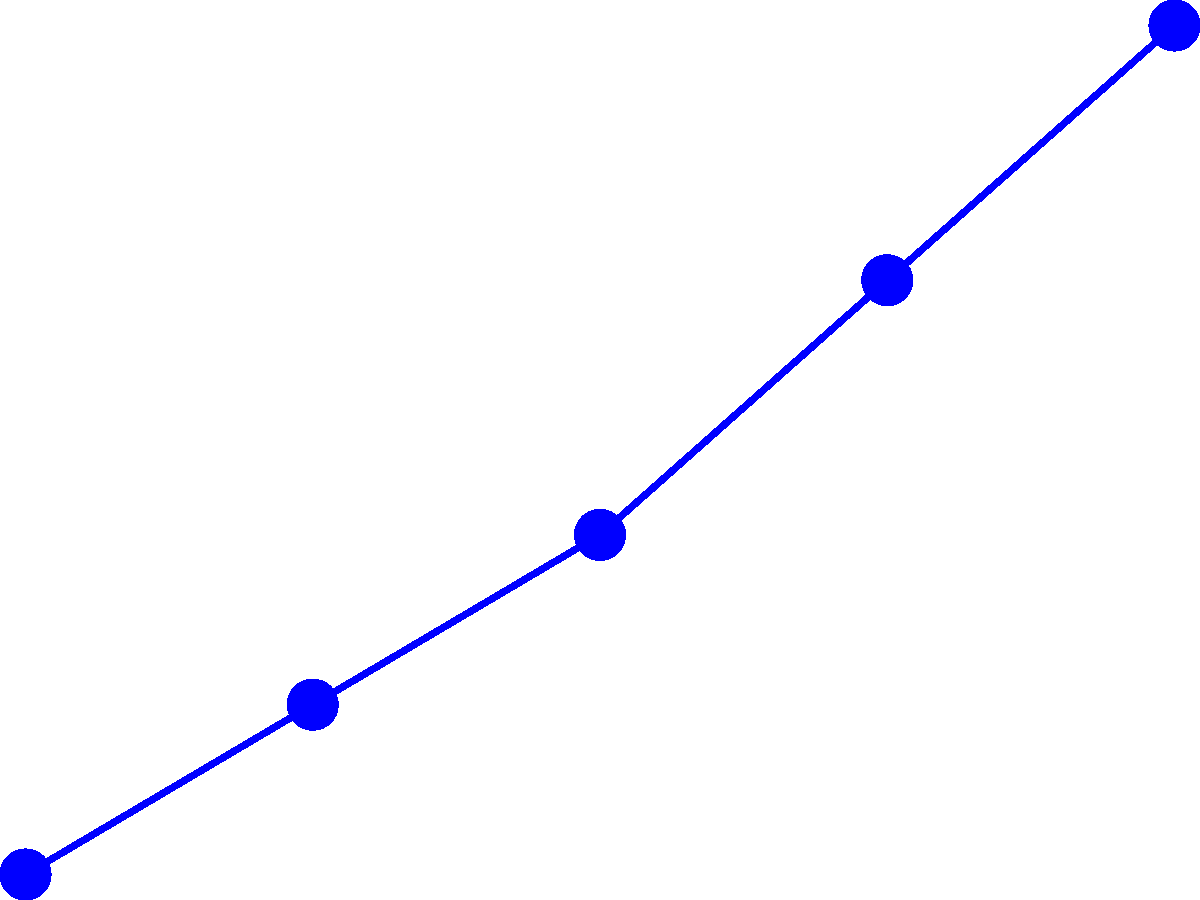Based on the line graph showing employee retention rates from 2018 to 2022, what is the average difference in retention rates between companies that implemented team-building events and those that did not? Round your answer to the nearest whole percentage point. To solve this problem, we need to follow these steps:

1. Calculate the difference in retention rates for each year:
   2018: 85% - 80% = 5%
   2019: 87% - 81% = 6%
   2020: 89% - 79% = 10%
   2021: 92% - 82% = 10%
   2022: 95% - 84% = 11%

2. Sum up all the differences:
   5% + 6% + 10% + 10% + 11% = 42%

3. Calculate the average by dividing the sum by the number of years (5):
   42% ÷ 5 = 8.4%

4. Round to the nearest whole percentage point:
   8.4% rounds to 8%

Therefore, the average difference in retention rates between companies that implemented team-building events and those that did not is 8 percentage points.
Answer: 8% 